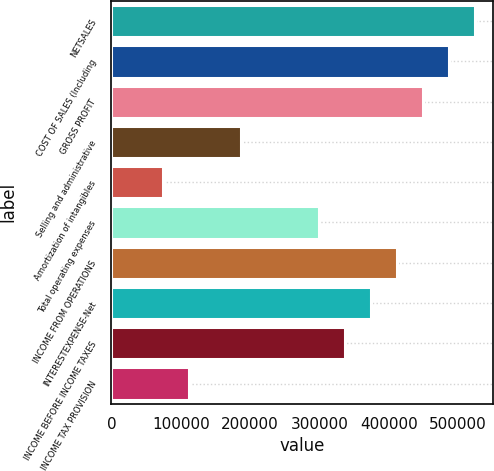Convert chart to OTSL. <chart><loc_0><loc_0><loc_500><loc_500><bar_chart><fcel>NETSALES<fcel>COST OF SALES (Including<fcel>GROSS PROFIT<fcel>Selling and administrative<fcel>Amortization of intangibles<fcel>Total operating expenses<fcel>INCOME FROM OPERATIONS<fcel>INTERESTEXPENSE-Net<fcel>INCOME BEFORE INCOME TAXES<fcel>INCOME TAX PROVISION<nl><fcel>523954<fcel>486529<fcel>449103<fcel>187127<fcel>74851.2<fcel>299403<fcel>411678<fcel>374253<fcel>336828<fcel>112276<nl></chart> 